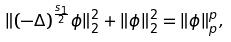<formula> <loc_0><loc_0><loc_500><loc_500>\| ( - \Delta ) ^ { \frac { s _ { 1 } } { 2 } } \phi \| _ { 2 } ^ { 2 } + \| \phi \| _ { 2 } ^ { 2 } = \| \phi \| _ { p } ^ { p } ,</formula> 